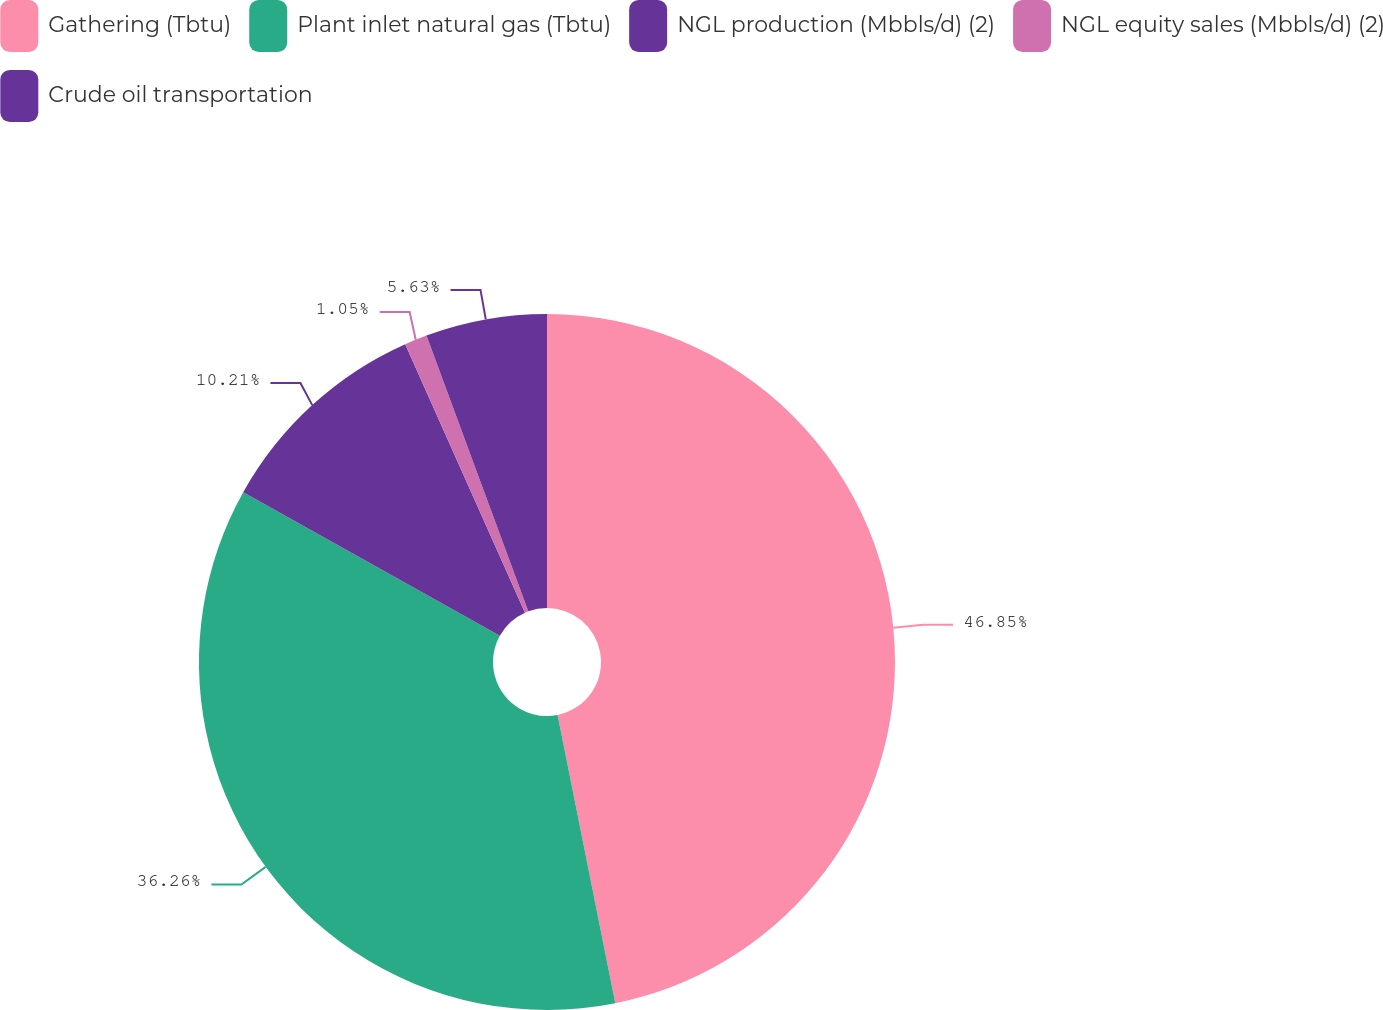<chart> <loc_0><loc_0><loc_500><loc_500><pie_chart><fcel>Gathering (Tbtu)<fcel>Plant inlet natural gas (Tbtu)<fcel>NGL production (Mbbls/d) (2)<fcel>NGL equity sales (Mbbls/d) (2)<fcel>Crude oil transportation<nl><fcel>46.86%<fcel>36.26%<fcel>10.21%<fcel>1.05%<fcel>5.63%<nl></chart> 